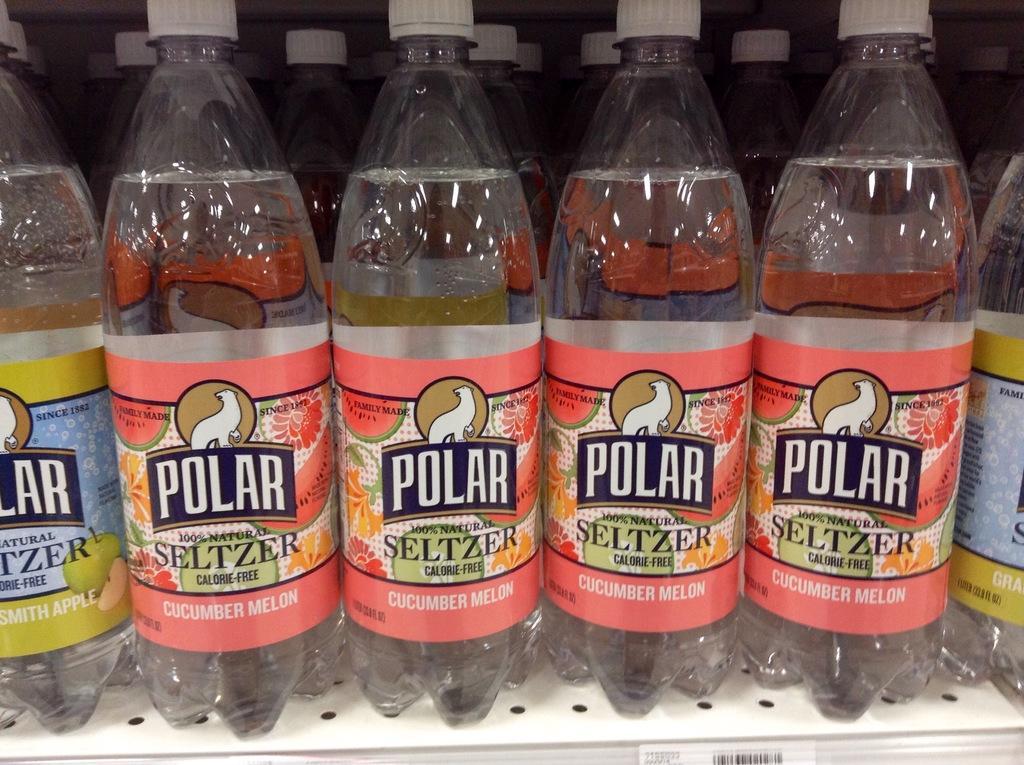Could you give a brief overview of what you see in this image? There are water bottles placed in a shelf. 